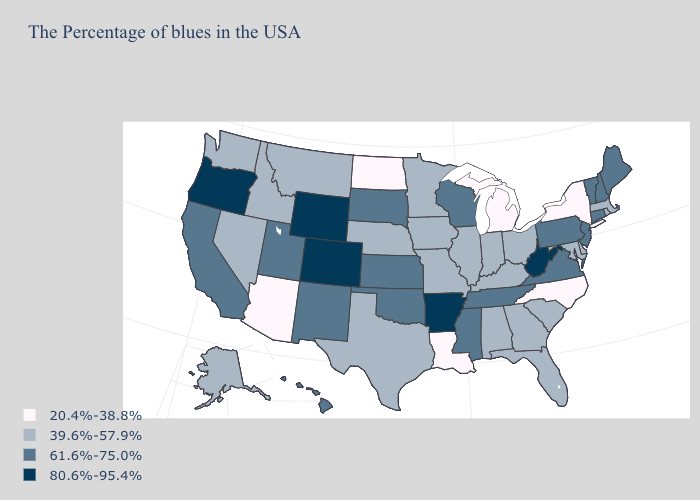What is the lowest value in the Northeast?
Keep it brief. 20.4%-38.8%. Name the states that have a value in the range 61.6%-75.0%?
Be succinct. Maine, New Hampshire, Vermont, Connecticut, New Jersey, Pennsylvania, Virginia, Tennessee, Wisconsin, Mississippi, Kansas, Oklahoma, South Dakota, New Mexico, Utah, California, Hawaii. What is the lowest value in the USA?
Keep it brief. 20.4%-38.8%. What is the lowest value in the West?
Keep it brief. 20.4%-38.8%. Which states hav the highest value in the MidWest?
Quick response, please. Wisconsin, Kansas, South Dakota. Does Mississippi have the same value as Delaware?
Answer briefly. No. Does Connecticut have the lowest value in the USA?
Write a very short answer. No. What is the value of Ohio?
Concise answer only. 39.6%-57.9%. Name the states that have a value in the range 39.6%-57.9%?
Give a very brief answer. Massachusetts, Rhode Island, Delaware, Maryland, South Carolina, Ohio, Florida, Georgia, Kentucky, Indiana, Alabama, Illinois, Missouri, Minnesota, Iowa, Nebraska, Texas, Montana, Idaho, Nevada, Washington, Alaska. What is the lowest value in states that border Missouri?
Write a very short answer. 39.6%-57.9%. What is the lowest value in states that border North Dakota?
Answer briefly. 39.6%-57.9%. Name the states that have a value in the range 80.6%-95.4%?
Answer briefly. West Virginia, Arkansas, Wyoming, Colorado, Oregon. Does Colorado have the highest value in the USA?
Short answer required. Yes. What is the highest value in the USA?
Keep it brief. 80.6%-95.4%. What is the value of Michigan?
Quick response, please. 20.4%-38.8%. 